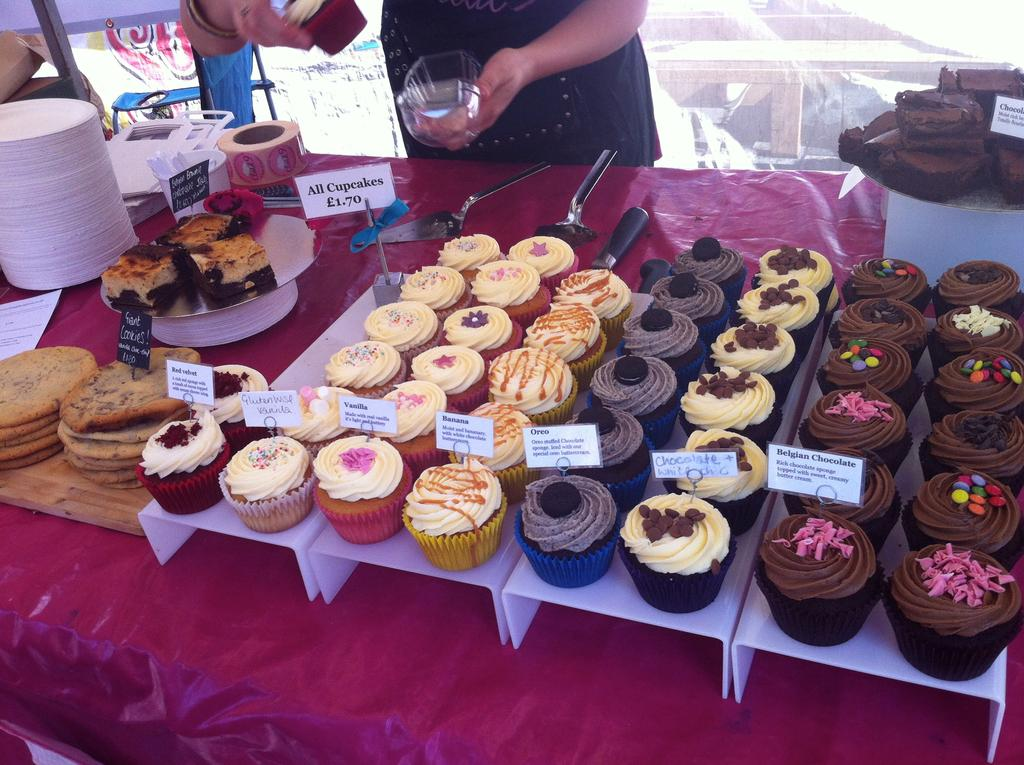What is the man in the image doing? The man is standing in the image and holding a glass. What is on the table in the image? There are cupcakes and plates on the table in the image. Can you describe the table in the image? There is a table in the image, but no specific details about its appearance are provided. What might the man be using the glass for? The man might be using the glass to drink or hold a beverage. What type of metal is the representative using to pickle the cupcakes in the image? There is no representative or pickling activity present in the image. 